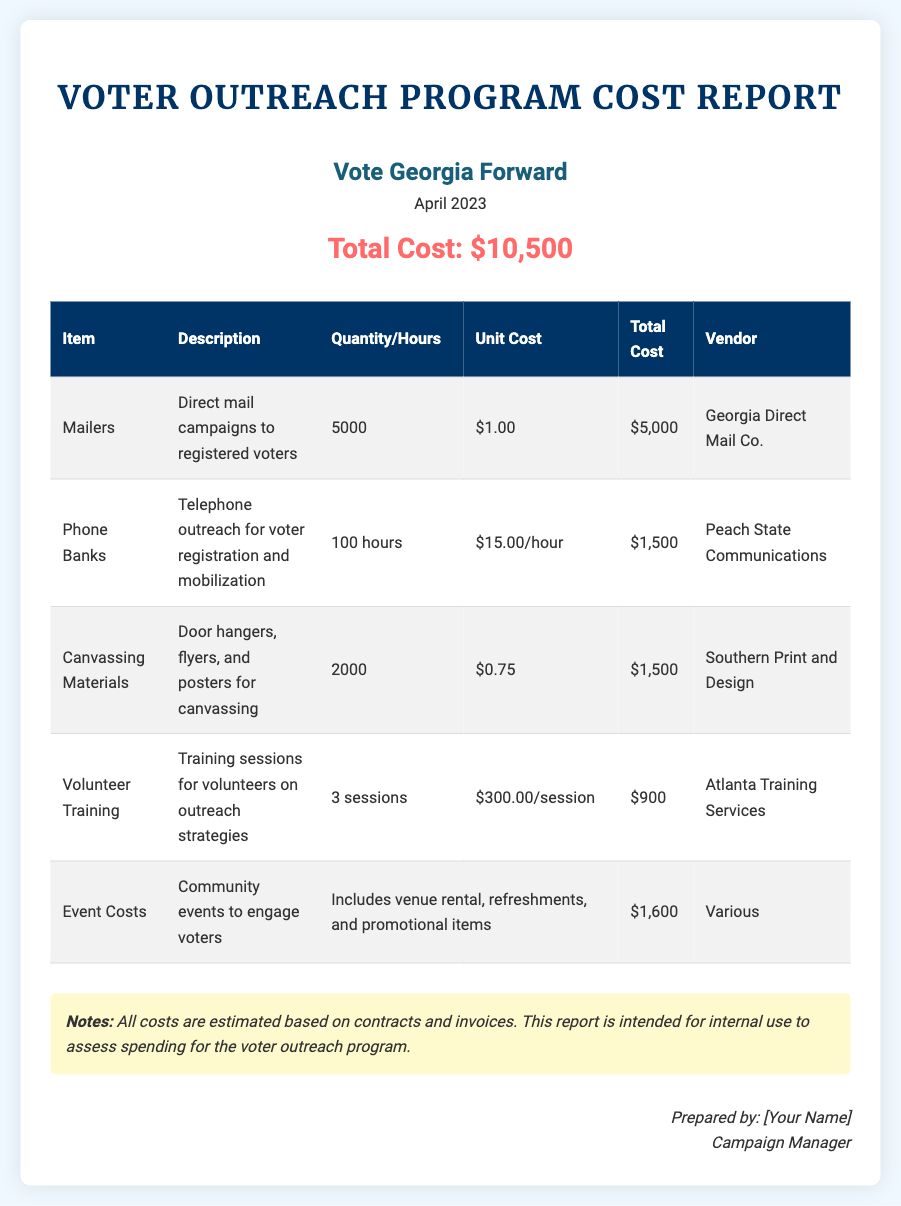What is the campaign name? The campaign name is presented at the top of the document and specifies which organization is responsible for the report.
Answer: Vote Georgia Forward What is the total cost of the voter outreach program? The total cost is summarized clearly in the document, showing the aggregate expense for the program.
Answer: $10,500 How many mailers were sent out? The number of mailers is detailed in the itemized cost table of the report.
Answer: 5000 What is the unit cost of phone banks? The document specifies the cost per hour for the phone bank services, which can be found in the table.
Answer: $15.00/hour What is the total cost for canvassing materials? The total cost can be found in the itemized costs section of the report specifically for canvassing materials.
Answer: $1,500 Which vendor provided the mailers? The report lists the vendors associated with each item in the cost table.
Answer: Georgia Direct Mail Co How many sessions were held for volunteer training? The training sessions for volunteers are specifically described in the itemized cost section.
Answer: 3 sessions What additional items are included in event costs? The document provides details about what is included in the event costs in the table.
Answer: Venue rental, refreshments, and promotional items What year is this report for? The report indicates the specific year in the header, which is essential for context.
Answer: 2023 